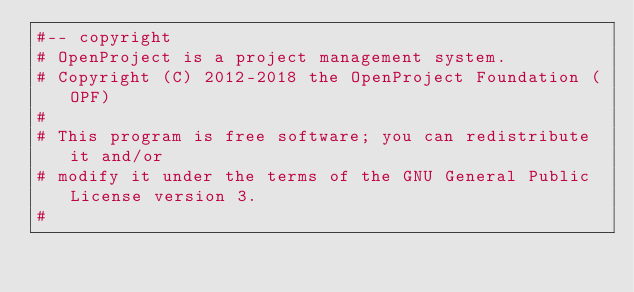Convert code to text. <code><loc_0><loc_0><loc_500><loc_500><_Ruby_>#-- copyright
# OpenProject is a project management system.
# Copyright (C) 2012-2018 the OpenProject Foundation (OPF)
#
# This program is free software; you can redistribute it and/or
# modify it under the terms of the GNU General Public License version 3.
#</code> 